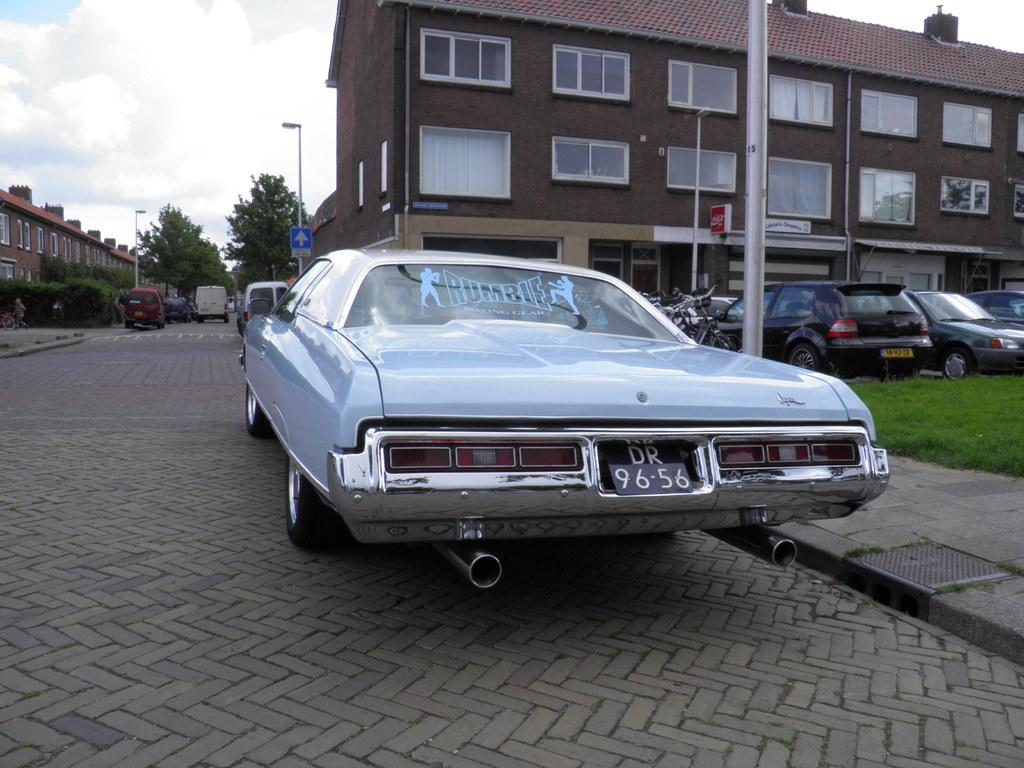What type of structure is visible in the image? There is a building in the image. What can be seen on the pavement in the image? Cars are present on the pavement. What objects are standing upright in the image? There are poles in the image. What type of vegetation is visible in the image? Plants and trees are present in the image. What type of collar ball can be seen in the image? There is no sense, collar, or ball present in the image. 